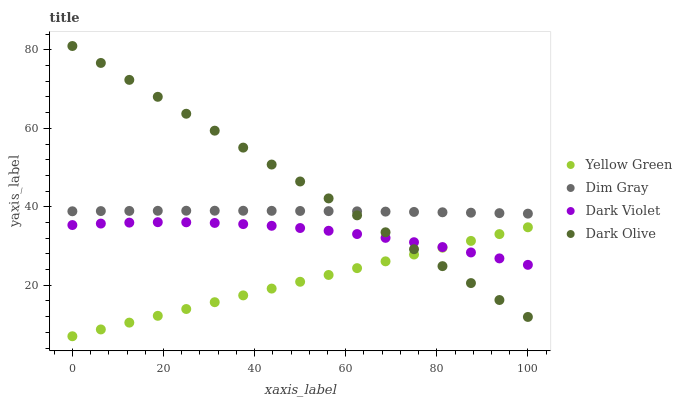Does Yellow Green have the minimum area under the curve?
Answer yes or no. Yes. Does Dark Olive have the maximum area under the curve?
Answer yes or no. Yes. Does Dim Gray have the minimum area under the curve?
Answer yes or no. No. Does Dim Gray have the maximum area under the curve?
Answer yes or no. No. Is Yellow Green the smoothest?
Answer yes or no. Yes. Is Dark Violet the roughest?
Answer yes or no. Yes. Is Dim Gray the smoothest?
Answer yes or no. No. Is Dim Gray the roughest?
Answer yes or no. No. Does Yellow Green have the lowest value?
Answer yes or no. Yes. Does Dim Gray have the lowest value?
Answer yes or no. No. Does Dark Olive have the highest value?
Answer yes or no. Yes. Does Dim Gray have the highest value?
Answer yes or no. No. Is Yellow Green less than Dim Gray?
Answer yes or no. Yes. Is Dim Gray greater than Yellow Green?
Answer yes or no. Yes. Does Yellow Green intersect Dark Olive?
Answer yes or no. Yes. Is Yellow Green less than Dark Olive?
Answer yes or no. No. Is Yellow Green greater than Dark Olive?
Answer yes or no. No. Does Yellow Green intersect Dim Gray?
Answer yes or no. No. 